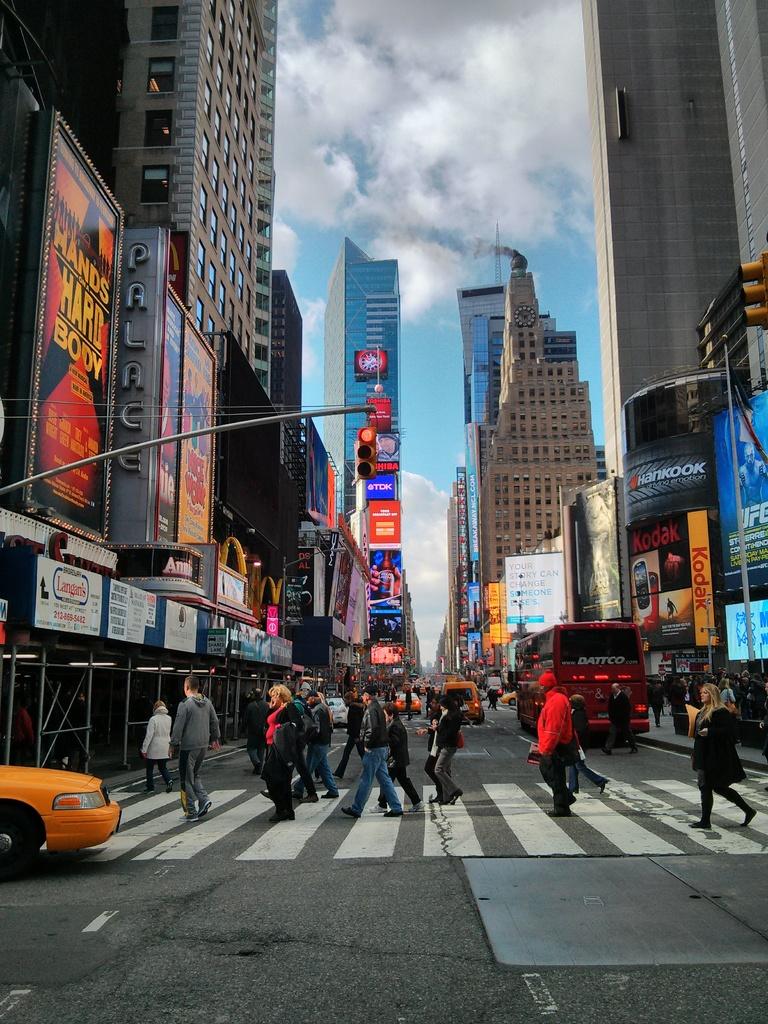What film company is on the yellow sign?
Your answer should be compact. Kodak. Is this a bust stop?
Provide a short and direct response. No. 